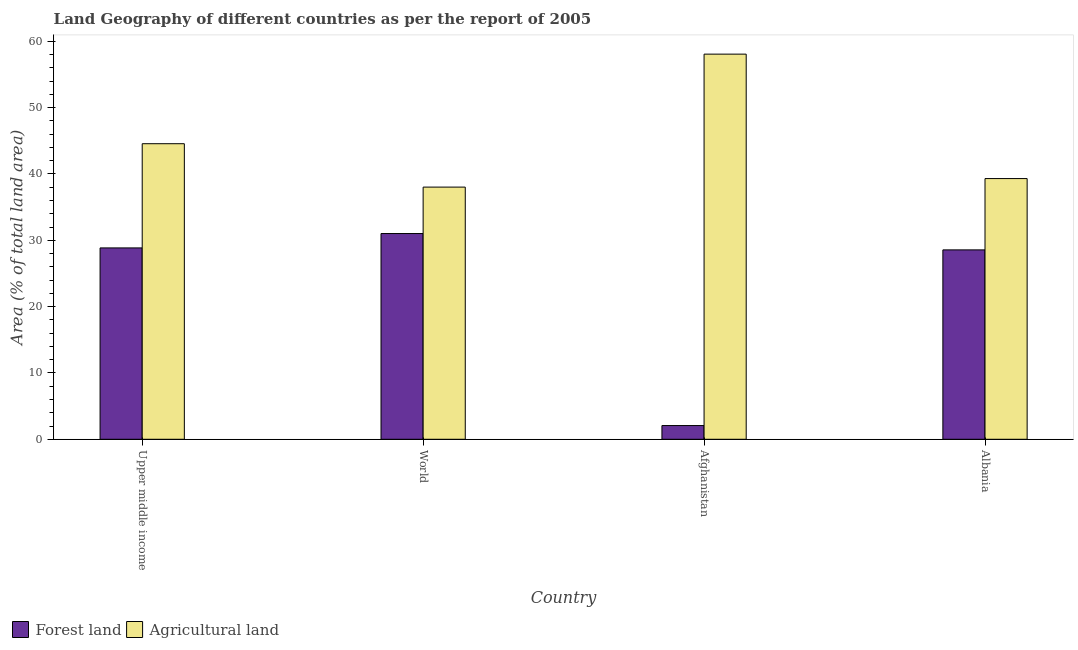How many groups of bars are there?
Offer a terse response. 4. Are the number of bars per tick equal to the number of legend labels?
Your response must be concise. Yes. Are the number of bars on each tick of the X-axis equal?
Offer a very short reply. Yes. How many bars are there on the 2nd tick from the left?
Ensure brevity in your answer.  2. What is the label of the 3rd group of bars from the left?
Keep it short and to the point. Afghanistan. What is the percentage of land area under agriculture in Albania?
Offer a very short reply. 39.31. Across all countries, what is the maximum percentage of land area under agriculture?
Ensure brevity in your answer.  58.07. Across all countries, what is the minimum percentage of land area under agriculture?
Offer a very short reply. 38.02. In which country was the percentage of land area under agriculture maximum?
Provide a short and direct response. Afghanistan. In which country was the percentage of land area under forests minimum?
Your answer should be compact. Afghanistan. What is the total percentage of land area under forests in the graph?
Your response must be concise. 90.49. What is the difference between the percentage of land area under agriculture in Afghanistan and that in Albania?
Your answer should be compact. 18.76. What is the difference between the percentage of land area under agriculture in Afghanistan and the percentage of land area under forests in Upper middle income?
Your answer should be very brief. 29.22. What is the average percentage of land area under agriculture per country?
Your response must be concise. 44.99. What is the difference between the percentage of land area under agriculture and percentage of land area under forests in Upper middle income?
Your answer should be very brief. 15.71. What is the ratio of the percentage of land area under agriculture in Afghanistan to that in World?
Your answer should be compact. 1.53. What is the difference between the highest and the second highest percentage of land area under agriculture?
Your answer should be compact. 13.51. What is the difference between the highest and the lowest percentage of land area under agriculture?
Make the answer very short. 20.05. In how many countries, is the percentage of land area under agriculture greater than the average percentage of land area under agriculture taken over all countries?
Give a very brief answer. 1. Is the sum of the percentage of land area under agriculture in Afghanistan and World greater than the maximum percentage of land area under forests across all countries?
Give a very brief answer. Yes. What does the 2nd bar from the left in Upper middle income represents?
Offer a very short reply. Agricultural land. What does the 2nd bar from the right in Afghanistan represents?
Make the answer very short. Forest land. How many bars are there?
Offer a very short reply. 8. Does the graph contain any zero values?
Give a very brief answer. No. Where does the legend appear in the graph?
Offer a terse response. Bottom left. How many legend labels are there?
Keep it short and to the point. 2. How are the legend labels stacked?
Ensure brevity in your answer.  Horizontal. What is the title of the graph?
Ensure brevity in your answer.  Land Geography of different countries as per the report of 2005. Does "Excluding technical cooperation" appear as one of the legend labels in the graph?
Your response must be concise. No. What is the label or title of the X-axis?
Give a very brief answer. Country. What is the label or title of the Y-axis?
Make the answer very short. Area (% of total land area). What is the Area (% of total land area) of Forest land in Upper middle income?
Your answer should be very brief. 28.85. What is the Area (% of total land area) of Agricultural land in Upper middle income?
Ensure brevity in your answer.  44.56. What is the Area (% of total land area) in Forest land in World?
Offer a terse response. 31.02. What is the Area (% of total land area) of Agricultural land in World?
Your answer should be compact. 38.02. What is the Area (% of total land area) in Forest land in Afghanistan?
Make the answer very short. 2.07. What is the Area (% of total land area) in Agricultural land in Afghanistan?
Your answer should be compact. 58.07. What is the Area (% of total land area) in Forest land in Albania?
Your answer should be compact. 28.55. What is the Area (% of total land area) in Agricultural land in Albania?
Provide a succinct answer. 39.31. Across all countries, what is the maximum Area (% of total land area) in Forest land?
Your answer should be compact. 31.02. Across all countries, what is the maximum Area (% of total land area) in Agricultural land?
Keep it short and to the point. 58.07. Across all countries, what is the minimum Area (% of total land area) of Forest land?
Offer a terse response. 2.07. Across all countries, what is the minimum Area (% of total land area) in Agricultural land?
Make the answer very short. 38.02. What is the total Area (% of total land area) of Forest land in the graph?
Provide a succinct answer. 90.49. What is the total Area (% of total land area) of Agricultural land in the graph?
Offer a terse response. 179.96. What is the difference between the Area (% of total land area) of Forest land in Upper middle income and that in World?
Provide a succinct answer. -2.17. What is the difference between the Area (% of total land area) in Agricultural land in Upper middle income and that in World?
Offer a terse response. 6.54. What is the difference between the Area (% of total land area) of Forest land in Upper middle income and that in Afghanistan?
Offer a very short reply. 26.78. What is the difference between the Area (% of total land area) in Agricultural land in Upper middle income and that in Afghanistan?
Provide a short and direct response. -13.51. What is the difference between the Area (% of total land area) of Forest land in Upper middle income and that in Albania?
Your answer should be very brief. 0.3. What is the difference between the Area (% of total land area) of Agricultural land in Upper middle income and that in Albania?
Provide a short and direct response. 5.26. What is the difference between the Area (% of total land area) in Forest land in World and that in Afghanistan?
Your response must be concise. 28.95. What is the difference between the Area (% of total land area) of Agricultural land in World and that in Afghanistan?
Ensure brevity in your answer.  -20.05. What is the difference between the Area (% of total land area) of Forest land in World and that in Albania?
Provide a short and direct response. 2.46. What is the difference between the Area (% of total land area) of Agricultural land in World and that in Albania?
Make the answer very short. -1.29. What is the difference between the Area (% of total land area) of Forest land in Afghanistan and that in Albania?
Make the answer very short. -26.49. What is the difference between the Area (% of total land area) in Agricultural land in Afghanistan and that in Albania?
Your answer should be compact. 18.76. What is the difference between the Area (% of total land area) in Forest land in Upper middle income and the Area (% of total land area) in Agricultural land in World?
Give a very brief answer. -9.17. What is the difference between the Area (% of total land area) in Forest land in Upper middle income and the Area (% of total land area) in Agricultural land in Afghanistan?
Keep it short and to the point. -29.22. What is the difference between the Area (% of total land area) of Forest land in Upper middle income and the Area (% of total land area) of Agricultural land in Albania?
Keep it short and to the point. -10.45. What is the difference between the Area (% of total land area) in Forest land in World and the Area (% of total land area) in Agricultural land in Afghanistan?
Offer a very short reply. -27.05. What is the difference between the Area (% of total land area) in Forest land in World and the Area (% of total land area) in Agricultural land in Albania?
Give a very brief answer. -8.29. What is the difference between the Area (% of total land area) of Forest land in Afghanistan and the Area (% of total land area) of Agricultural land in Albania?
Keep it short and to the point. -37.24. What is the average Area (% of total land area) in Forest land per country?
Ensure brevity in your answer.  22.62. What is the average Area (% of total land area) of Agricultural land per country?
Your answer should be compact. 44.99. What is the difference between the Area (% of total land area) in Forest land and Area (% of total land area) in Agricultural land in Upper middle income?
Ensure brevity in your answer.  -15.71. What is the difference between the Area (% of total land area) in Forest land and Area (% of total land area) in Agricultural land in World?
Ensure brevity in your answer.  -7. What is the difference between the Area (% of total land area) in Forest land and Area (% of total land area) in Agricultural land in Afghanistan?
Your answer should be compact. -56. What is the difference between the Area (% of total land area) of Forest land and Area (% of total land area) of Agricultural land in Albania?
Provide a short and direct response. -10.75. What is the ratio of the Area (% of total land area) of Forest land in Upper middle income to that in World?
Provide a succinct answer. 0.93. What is the ratio of the Area (% of total land area) of Agricultural land in Upper middle income to that in World?
Your answer should be very brief. 1.17. What is the ratio of the Area (% of total land area) of Forest land in Upper middle income to that in Afghanistan?
Provide a short and direct response. 13.95. What is the ratio of the Area (% of total land area) in Agricultural land in Upper middle income to that in Afghanistan?
Ensure brevity in your answer.  0.77. What is the ratio of the Area (% of total land area) in Forest land in Upper middle income to that in Albania?
Your answer should be very brief. 1.01. What is the ratio of the Area (% of total land area) in Agricultural land in Upper middle income to that in Albania?
Your answer should be very brief. 1.13. What is the ratio of the Area (% of total land area) in Forest land in World to that in Afghanistan?
Ensure brevity in your answer.  15. What is the ratio of the Area (% of total land area) of Agricultural land in World to that in Afghanistan?
Provide a short and direct response. 0.65. What is the ratio of the Area (% of total land area) in Forest land in World to that in Albania?
Your response must be concise. 1.09. What is the ratio of the Area (% of total land area) in Agricultural land in World to that in Albania?
Keep it short and to the point. 0.97. What is the ratio of the Area (% of total land area) in Forest land in Afghanistan to that in Albania?
Provide a short and direct response. 0.07. What is the ratio of the Area (% of total land area) of Agricultural land in Afghanistan to that in Albania?
Keep it short and to the point. 1.48. What is the difference between the highest and the second highest Area (% of total land area) in Forest land?
Provide a short and direct response. 2.17. What is the difference between the highest and the second highest Area (% of total land area) of Agricultural land?
Your answer should be compact. 13.51. What is the difference between the highest and the lowest Area (% of total land area) in Forest land?
Offer a very short reply. 28.95. What is the difference between the highest and the lowest Area (% of total land area) of Agricultural land?
Keep it short and to the point. 20.05. 